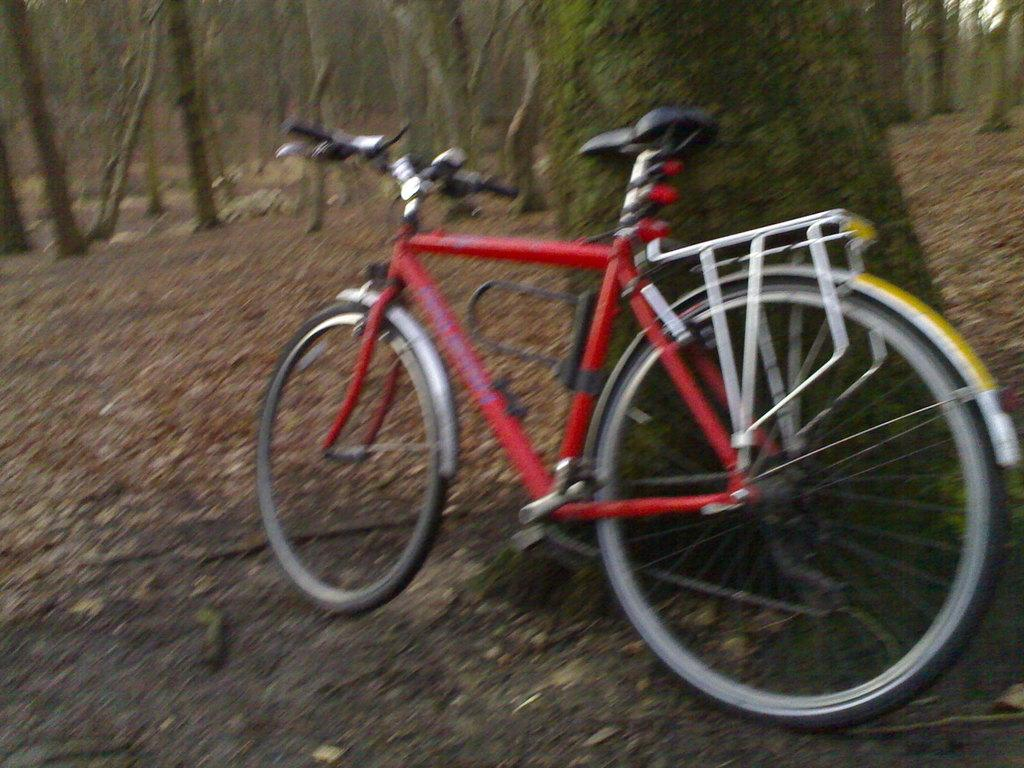What object is on the ground in the image? There is a bicycle on the ground in the image. What type of vegetation is present in the image? Shredded leaves are visible in the image. What can be seen in the background of the image? There are trees in the image. What is visible above the trees in the image? The sky is visible in the image. How many men are visible through the window in the image? There is no window present in the image, and therefore no men can be seen through it. 